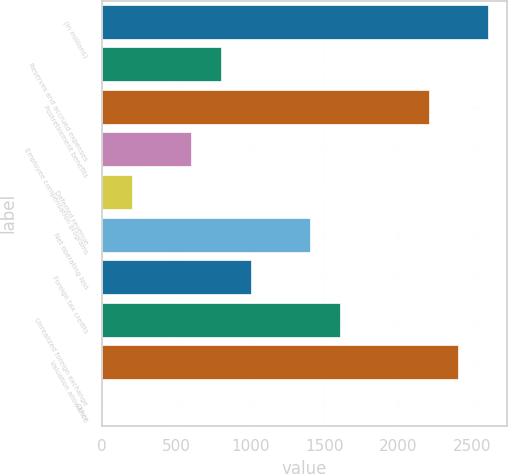<chart> <loc_0><loc_0><loc_500><loc_500><bar_chart><fcel>(in millions)<fcel>Reserves and accrued expenses<fcel>Postretirement benefits<fcel>Employee compensation programs<fcel>Deferred revenue<fcel>Net operating loss<fcel>Foreign tax credits<fcel>Unrealized foreign exchange<fcel>Valuation allowance<fcel>Other<nl><fcel>2603.94<fcel>804.12<fcel>2203.98<fcel>604.14<fcel>204.18<fcel>1404.06<fcel>1004.1<fcel>1604.04<fcel>2403.96<fcel>4.2<nl></chart> 